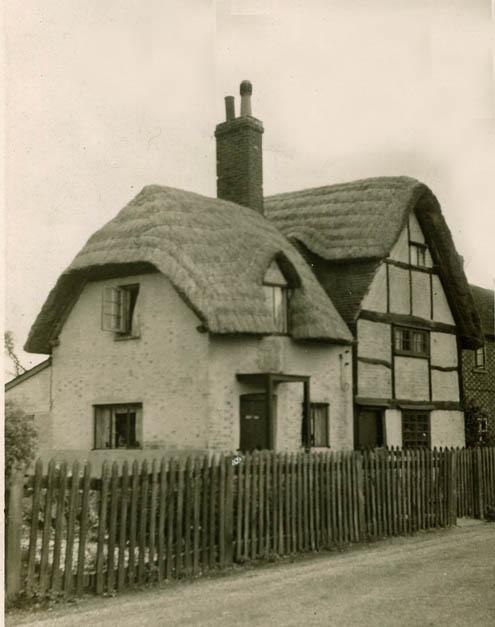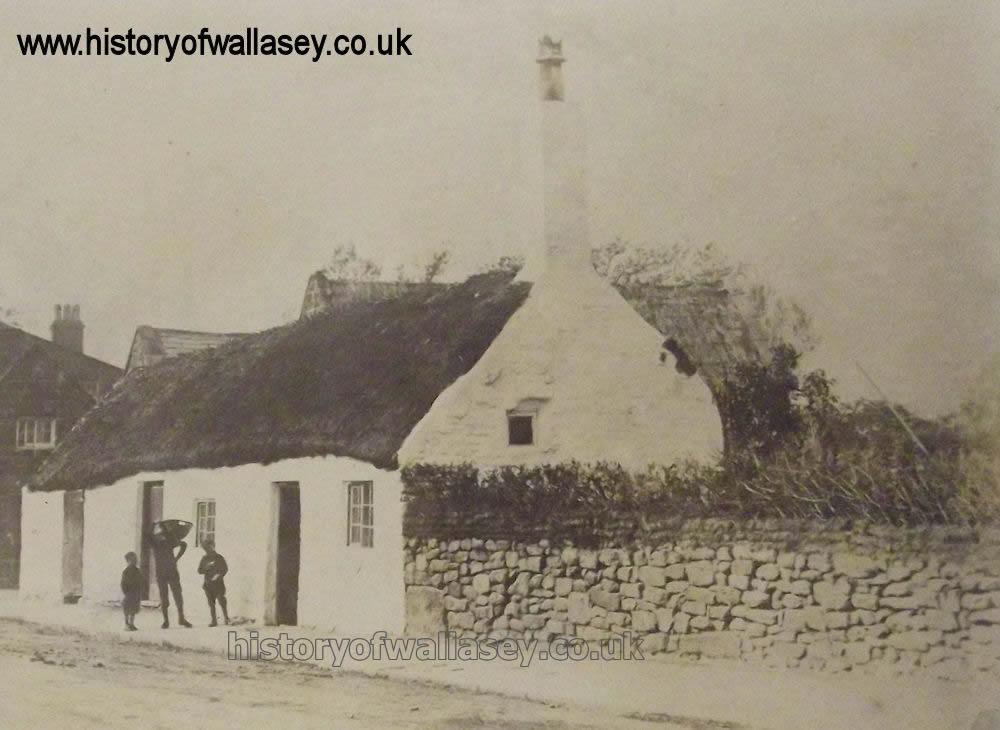The first image is the image on the left, the second image is the image on the right. Given the left and right images, does the statement "The left and right image contains the same number of full building with a single chimney on it." hold true? Answer yes or no. Yes. The first image is the image on the left, the second image is the image on the right. Considering the images on both sides, is "The building in the left image has exactly one chimney." valid? Answer yes or no. Yes. 